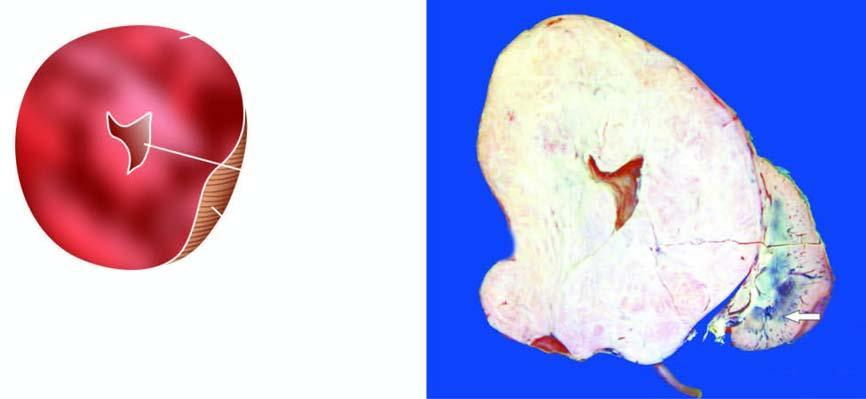what does the sectioned surface show?
Answer the question using a single word or phrase. Replacement of almost whole kidney 